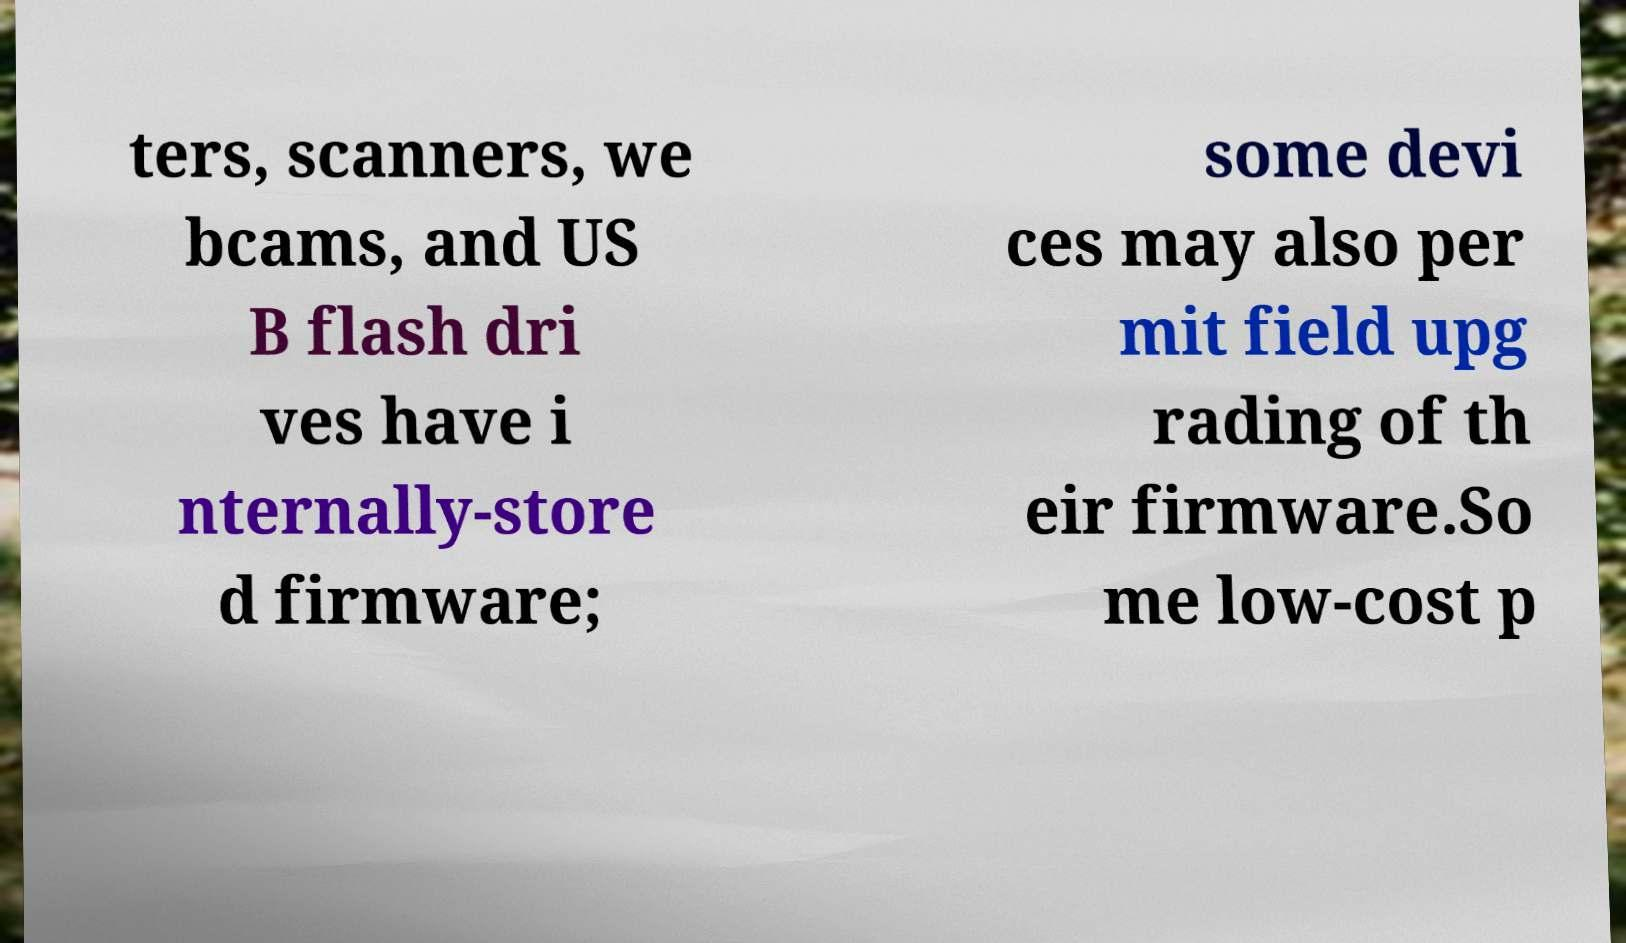What messages or text are displayed in this image? I need them in a readable, typed format. ters, scanners, we bcams, and US B flash dri ves have i nternally-store d firmware; some devi ces may also per mit field upg rading of th eir firmware.So me low-cost p 